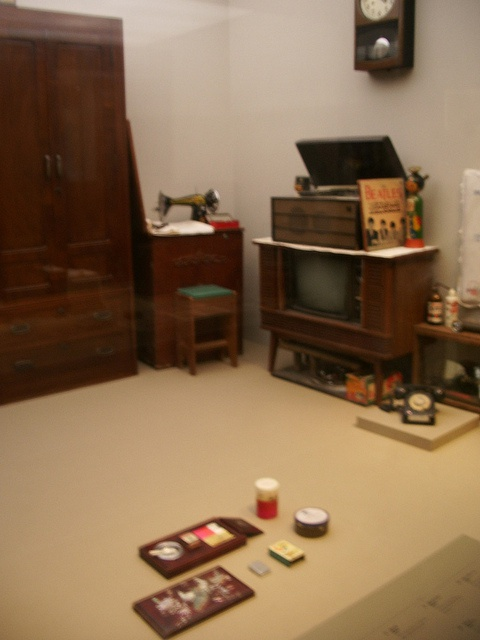Describe the objects in this image and their specific colors. I can see tv in black and gray tones, chair in gray, maroon, black, and darkgreen tones, book in gray, brown, maroon, and orange tones, bottle in gray, black, maroon, and brown tones, and clock in gray and tan tones in this image. 